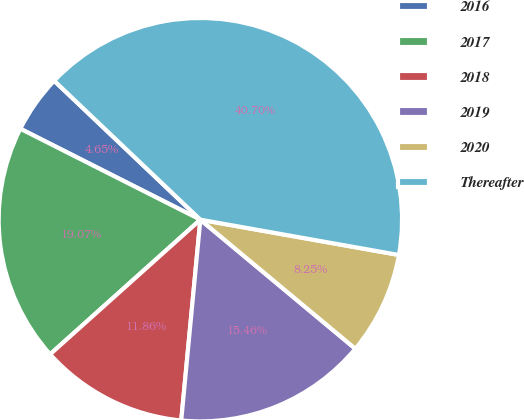<chart> <loc_0><loc_0><loc_500><loc_500><pie_chart><fcel>2016<fcel>2017<fcel>2018<fcel>2019<fcel>2020<fcel>Thereafter<nl><fcel>4.65%<fcel>19.07%<fcel>11.86%<fcel>15.46%<fcel>8.25%<fcel>40.7%<nl></chart> 